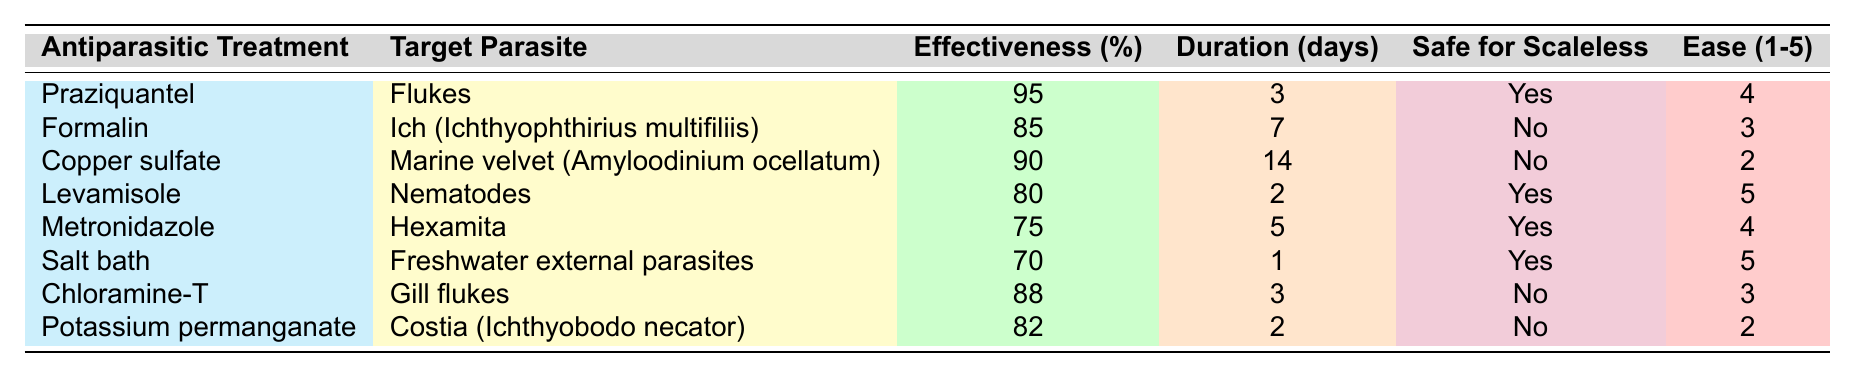What is the effectiveness of Praziquantel against flukes? The table indicates that Praziquantel has an effectiveness of 95% against flukes.
Answer: 95% How many days does Copper sulfate treatment last? According to the table, Copper sulfate treatment lasts for 14 days.
Answer: 14 days Are Levamisole and Salting treatments safe for scaleless fish? The table shows that Levamisole and Salt bath treatments are both marked as "Yes" for being safe for scaleless fish.
Answer: Yes What is the average effectiveness of all the treatments listed? To find the average effectiveness, we sum all effectiveness percentages (95 + 85 + 90 + 80 + 75 + 70 + 88 + 82 =  715), then divide by the number of treatments (8). Thus, the average effectiveness is 715 / 8 = 89.375%.
Answer: 89.375% Is Metronidazole easier to use than Copper sulfate? The ease of use ratings indicate that Metronidazole has a rating of 4 while Copper sulfate has a rating of 2. Since 4 is higher than 2, Metronidazole is easier to use.
Answer: Yes Which treatment has the highest effectiveness, and what is it? By reviewing the effectiveness percentages, Praziquantel has the highest effectiveness listed at 95%.
Answer: Praziquantel, 95% How many treatments take longer than 5 days? Looking at the treatment durations, only Formalin (7 days) and Copper sulfate (14 days) take longer than 5 days, making a total of 2 treatments.
Answer: 2 treatments Which treatments are safe for scaleless fish? The table shows that Praziquantel, Levamisole, Metronidazole, and Salt bath treatments are safe for scaleless fish.
Answer: Praziquantel, Levamisole, Metronidazole, Salt bath What is the total number of days for treatments that take 3 days or less? The treatments that take 3 days or less are Praziquantel (3), Levamisole (2), and Salt bath (1). The sum of these durations is 3 + 2 + 1 = 6 days.
Answer: 6 days Is the effectiveness of Copper sulfate greater than that of Metronidazole? Copper sulfate has an effectiveness of 90%, while Metronidazole has 75%. Since 90% is greater than 75%, the effectiveness of Copper sulfate is higher.
Answer: Yes 